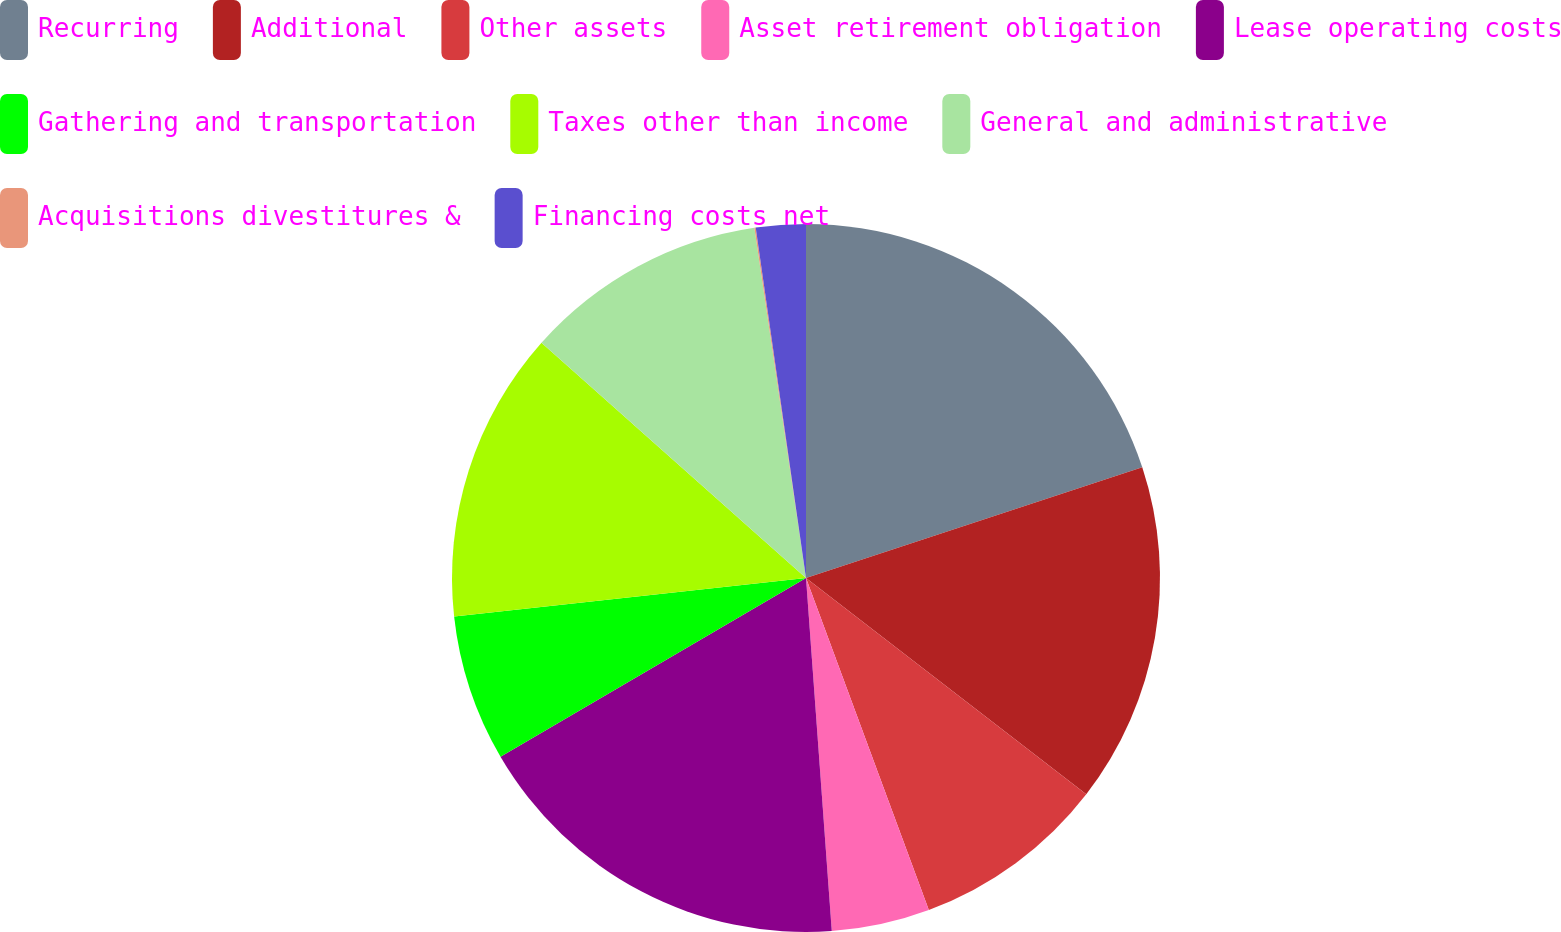<chart> <loc_0><loc_0><loc_500><loc_500><pie_chart><fcel>Recurring<fcel>Additional<fcel>Other assets<fcel>Asset retirement obligation<fcel>Lease operating costs<fcel>Gathering and transportation<fcel>Taxes other than income<fcel>General and administrative<fcel>Acquisitions divestitures &<fcel>Financing costs net<nl><fcel>19.94%<fcel>15.52%<fcel>8.9%<fcel>4.48%<fcel>17.73%<fcel>6.69%<fcel>13.31%<fcel>11.1%<fcel>0.06%<fcel>2.27%<nl></chart> 